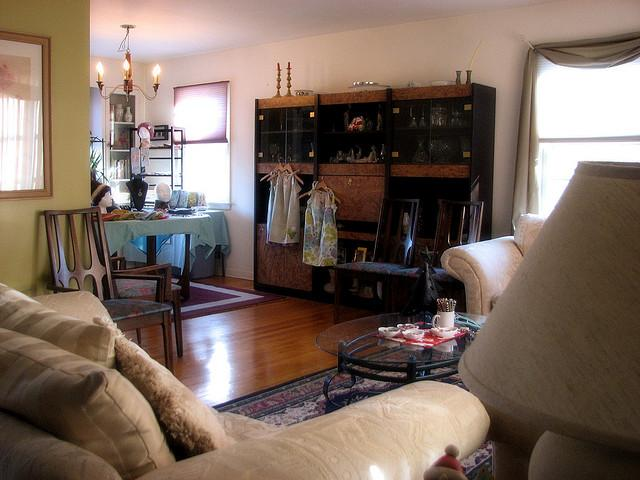Why are the clothes on hangers?

Choices:
A) for sale
B) hiding
C) airing out
D) cleaning airing out 